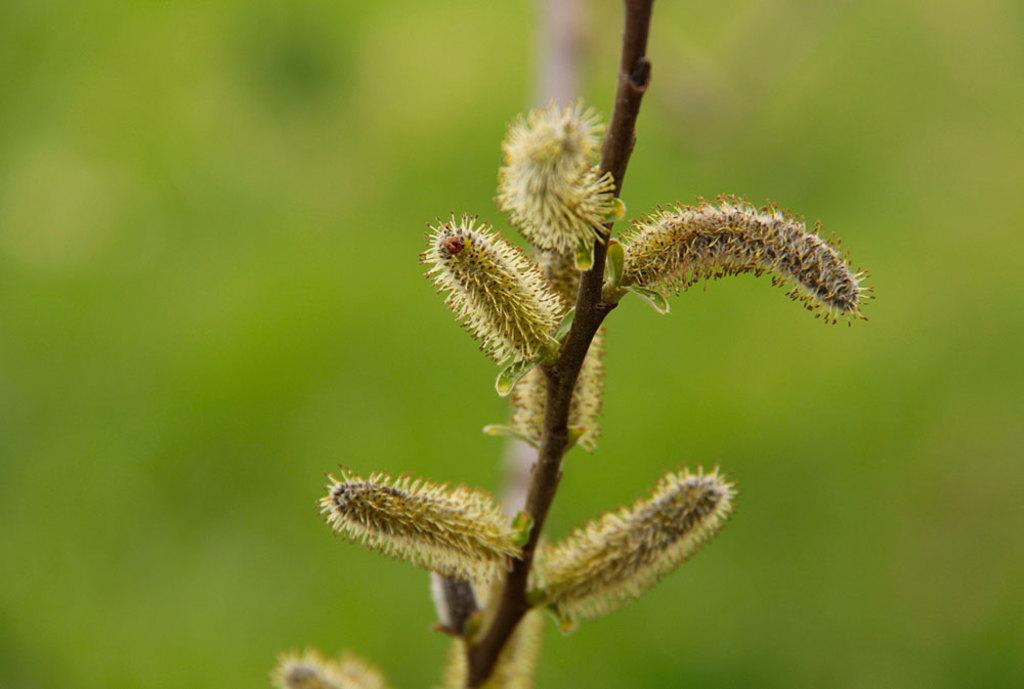What is the main subject of the image? The main subject of the image is a branch of a plant. Are there any living organisms visible on the plant? Yes, insects are present on the plant. How does the plant help with the insurance policy in the image? The image does not show any connection to an insurance policy, so it cannot be determined how the plant might be related to one. 